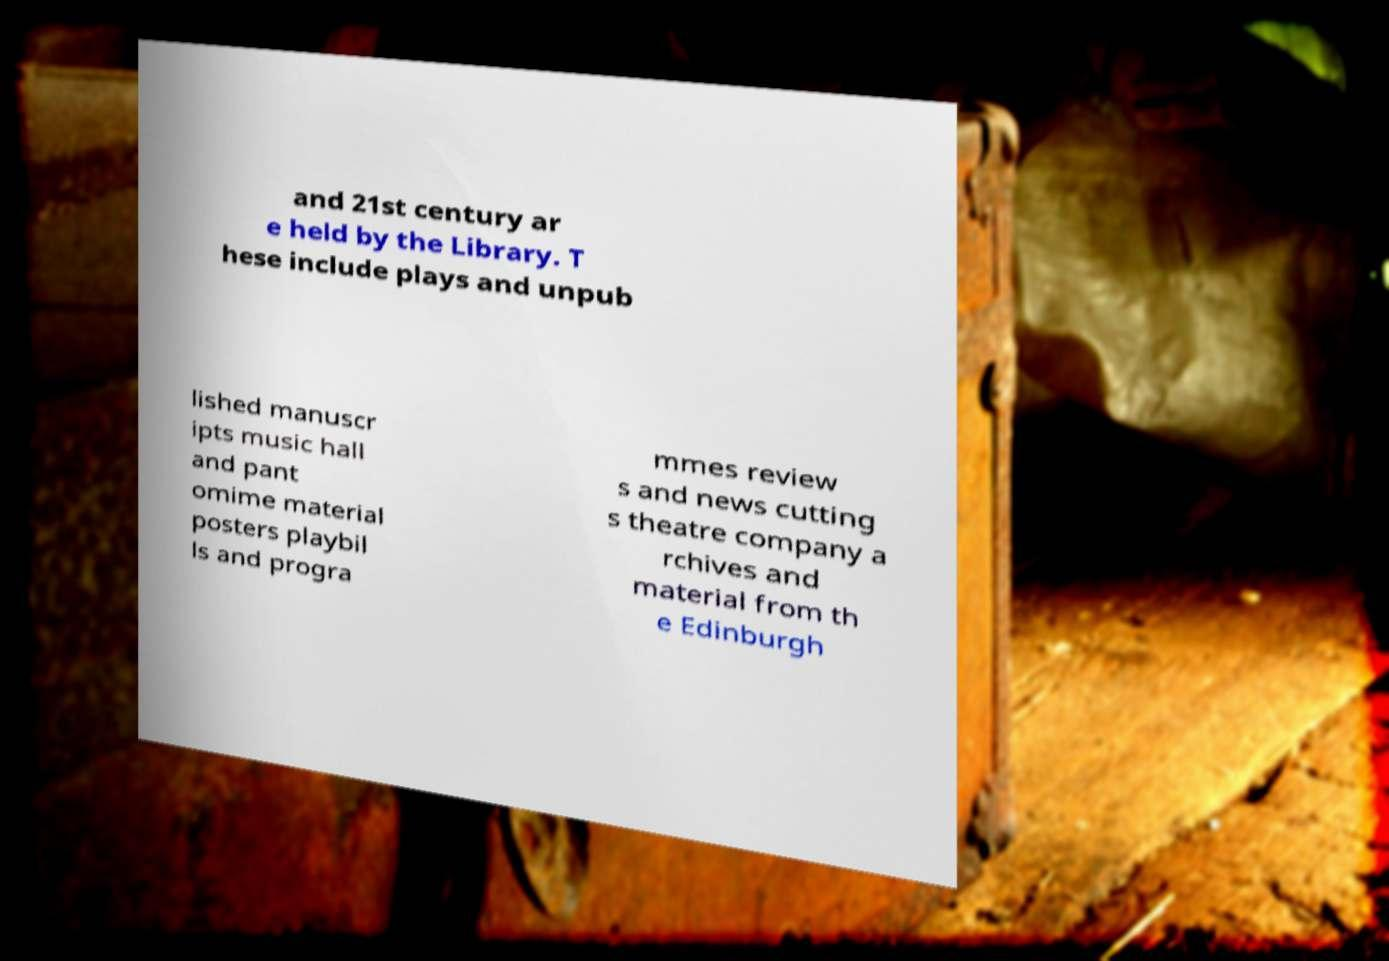What messages or text are displayed in this image? I need them in a readable, typed format. and 21st century ar e held by the Library. T hese include plays and unpub lished manuscr ipts music hall and pant omime material posters playbil ls and progra mmes review s and news cutting s theatre company a rchives and material from th e Edinburgh 